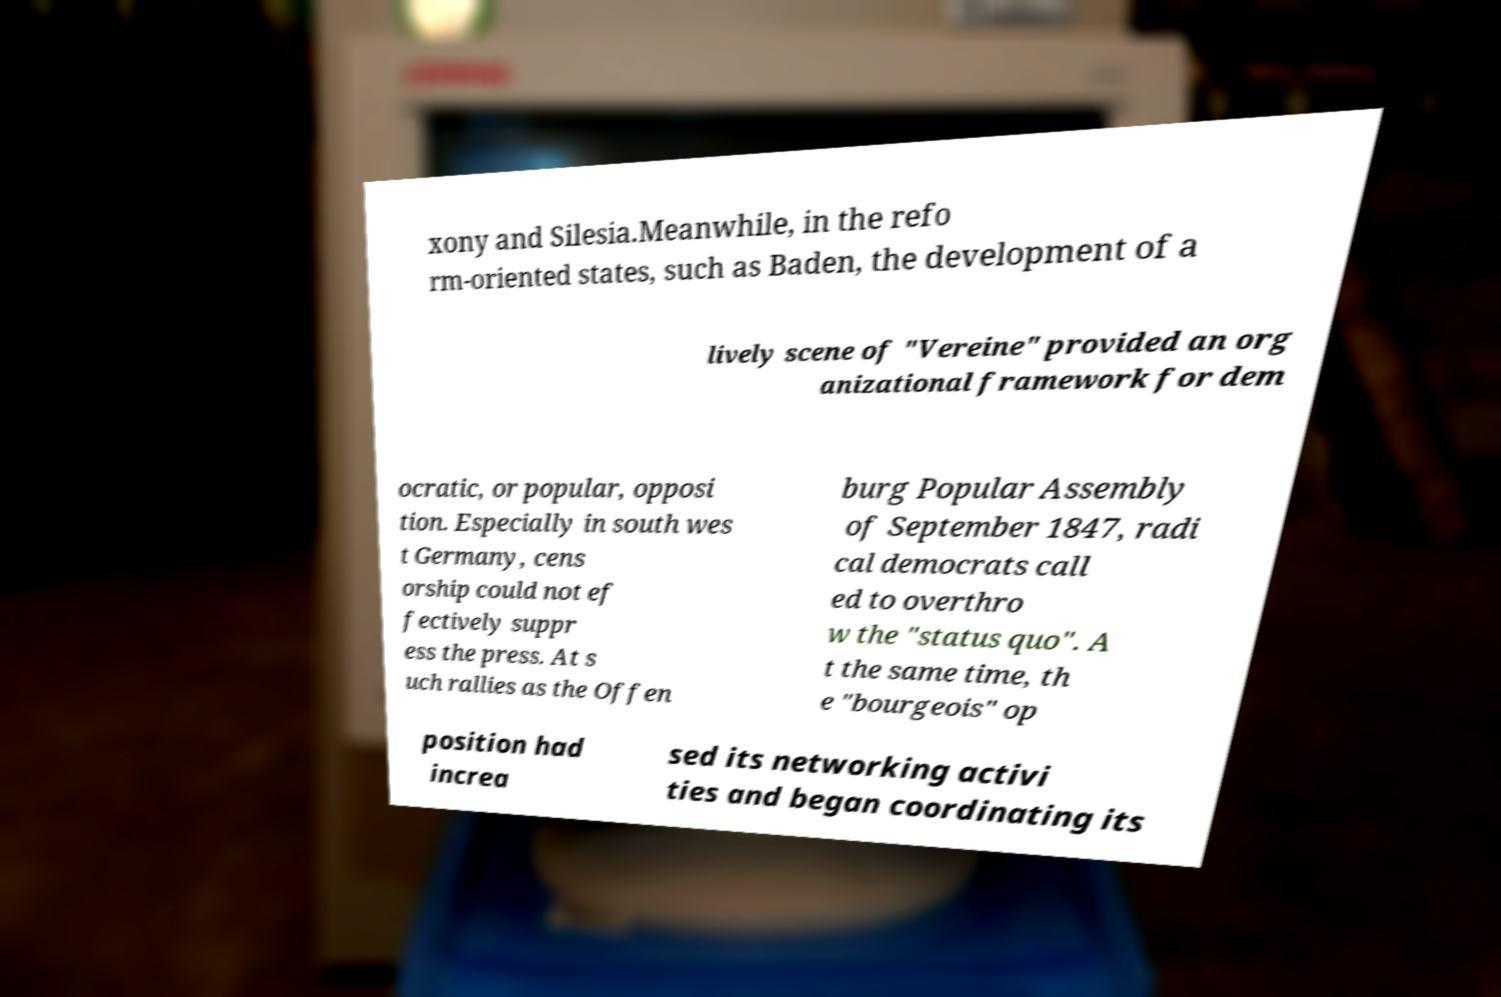For documentation purposes, I need the text within this image transcribed. Could you provide that? xony and Silesia.Meanwhile, in the refo rm-oriented states, such as Baden, the development of a lively scene of "Vereine" provided an org anizational framework for dem ocratic, or popular, opposi tion. Especially in south wes t Germany, cens orship could not ef fectively suppr ess the press. At s uch rallies as the Offen burg Popular Assembly of September 1847, radi cal democrats call ed to overthro w the "status quo". A t the same time, th e "bourgeois" op position had increa sed its networking activi ties and began coordinating its 